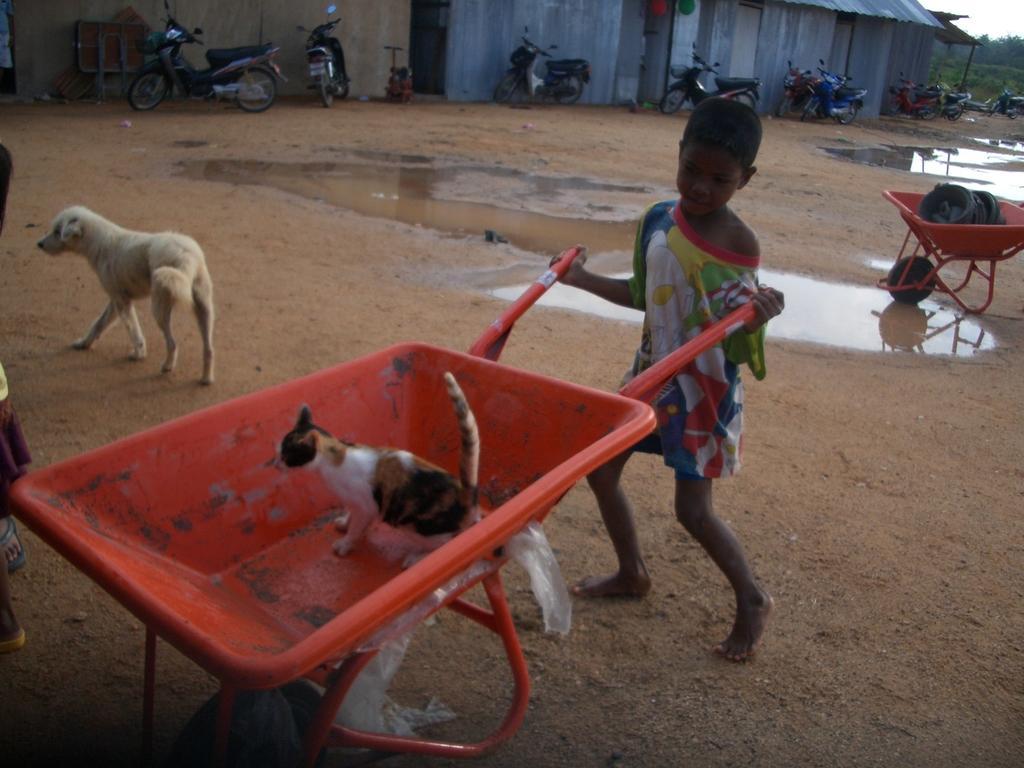Can you describe this image briefly? In this image I can see a kid. I can see a cat. I can see a dog. I can see the water. In the background, I can see the vehicles. 